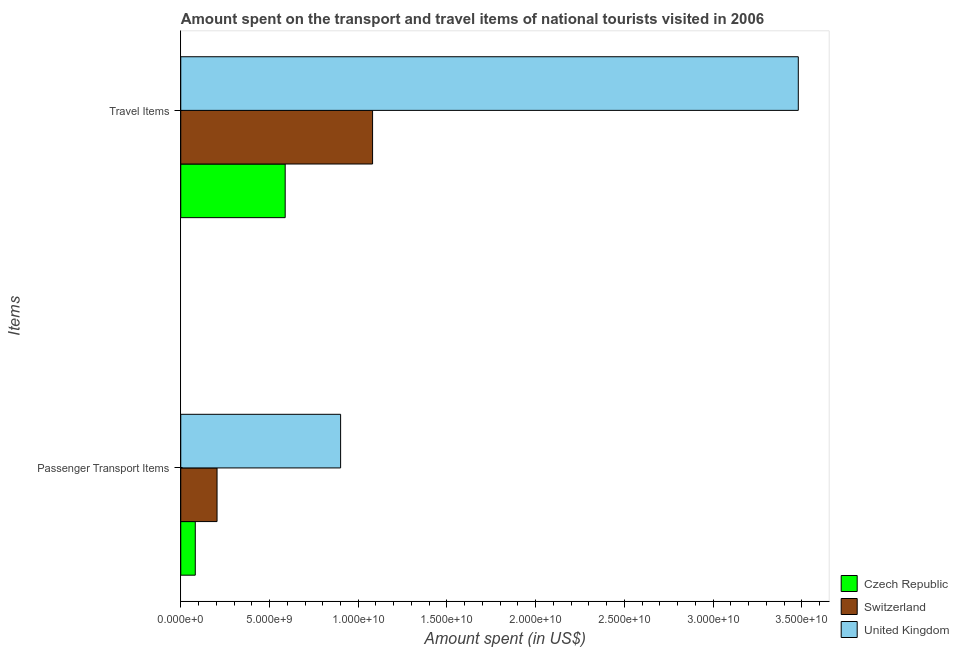Are the number of bars per tick equal to the number of legend labels?
Offer a very short reply. Yes. How many bars are there on the 2nd tick from the top?
Offer a terse response. 3. What is the label of the 2nd group of bars from the top?
Make the answer very short. Passenger Transport Items. What is the amount spent on passenger transport items in Czech Republic?
Your answer should be very brief. 8.18e+08. Across all countries, what is the maximum amount spent on passenger transport items?
Provide a succinct answer. 9.01e+09. Across all countries, what is the minimum amount spent on passenger transport items?
Your answer should be compact. 8.18e+08. In which country was the amount spent in travel items maximum?
Offer a terse response. United Kingdom. In which country was the amount spent on passenger transport items minimum?
Your response must be concise. Czech Republic. What is the total amount spent on passenger transport items in the graph?
Your response must be concise. 1.19e+1. What is the difference between the amount spent in travel items in Czech Republic and that in Switzerland?
Make the answer very short. -4.92e+09. What is the difference between the amount spent in travel items in United Kingdom and the amount spent on passenger transport items in Czech Republic?
Your answer should be very brief. 3.40e+1. What is the average amount spent on passenger transport items per country?
Give a very brief answer. 3.96e+09. What is the difference between the amount spent in travel items and amount spent on passenger transport items in Czech Republic?
Make the answer very short. 5.07e+09. What is the ratio of the amount spent on passenger transport items in Switzerland to that in Czech Republic?
Give a very brief answer. 2.5. What does the 2nd bar from the top in Passenger Transport Items represents?
Your response must be concise. Switzerland. What does the 1st bar from the bottom in Passenger Transport Items represents?
Your response must be concise. Czech Republic. How many bars are there?
Your answer should be compact. 6. How many countries are there in the graph?
Offer a terse response. 3. Are the values on the major ticks of X-axis written in scientific E-notation?
Ensure brevity in your answer.  Yes. Does the graph contain any zero values?
Make the answer very short. No. Does the graph contain grids?
Make the answer very short. No. How are the legend labels stacked?
Provide a succinct answer. Vertical. What is the title of the graph?
Your answer should be very brief. Amount spent on the transport and travel items of national tourists visited in 2006. What is the label or title of the X-axis?
Offer a terse response. Amount spent (in US$). What is the label or title of the Y-axis?
Give a very brief answer. Items. What is the Amount spent (in US$) in Czech Republic in Passenger Transport Items?
Offer a very short reply. 8.18e+08. What is the Amount spent (in US$) in Switzerland in Passenger Transport Items?
Provide a succinct answer. 2.04e+09. What is the Amount spent (in US$) of United Kingdom in Passenger Transport Items?
Give a very brief answer. 9.01e+09. What is the Amount spent (in US$) in Czech Republic in Travel Items?
Provide a succinct answer. 5.88e+09. What is the Amount spent (in US$) in Switzerland in Travel Items?
Your response must be concise. 1.08e+1. What is the Amount spent (in US$) of United Kingdom in Travel Items?
Make the answer very short. 3.48e+1. Across all Items, what is the maximum Amount spent (in US$) of Czech Republic?
Keep it short and to the point. 5.88e+09. Across all Items, what is the maximum Amount spent (in US$) of Switzerland?
Offer a very short reply. 1.08e+1. Across all Items, what is the maximum Amount spent (in US$) of United Kingdom?
Provide a short and direct response. 3.48e+1. Across all Items, what is the minimum Amount spent (in US$) of Czech Republic?
Offer a terse response. 8.18e+08. Across all Items, what is the minimum Amount spent (in US$) of Switzerland?
Make the answer very short. 2.04e+09. Across all Items, what is the minimum Amount spent (in US$) of United Kingdom?
Offer a terse response. 9.01e+09. What is the total Amount spent (in US$) in Czech Republic in the graph?
Ensure brevity in your answer.  6.70e+09. What is the total Amount spent (in US$) in Switzerland in the graph?
Provide a succinct answer. 1.29e+1. What is the total Amount spent (in US$) in United Kingdom in the graph?
Make the answer very short. 4.38e+1. What is the difference between the Amount spent (in US$) in Czech Republic in Passenger Transport Items and that in Travel Items?
Provide a short and direct response. -5.07e+09. What is the difference between the Amount spent (in US$) of Switzerland in Passenger Transport Items and that in Travel Items?
Offer a very short reply. -8.76e+09. What is the difference between the Amount spent (in US$) in United Kingdom in Passenger Transport Items and that in Travel Items?
Keep it short and to the point. -2.58e+1. What is the difference between the Amount spent (in US$) of Czech Republic in Passenger Transport Items and the Amount spent (in US$) of Switzerland in Travel Items?
Keep it short and to the point. -9.99e+09. What is the difference between the Amount spent (in US$) in Czech Republic in Passenger Transport Items and the Amount spent (in US$) in United Kingdom in Travel Items?
Provide a succinct answer. -3.40e+1. What is the difference between the Amount spent (in US$) in Switzerland in Passenger Transport Items and the Amount spent (in US$) in United Kingdom in Travel Items?
Offer a terse response. -3.28e+1. What is the average Amount spent (in US$) in Czech Republic per Items?
Your answer should be compact. 3.35e+09. What is the average Amount spent (in US$) of Switzerland per Items?
Your answer should be very brief. 6.43e+09. What is the average Amount spent (in US$) in United Kingdom per Items?
Your answer should be compact. 2.19e+1. What is the difference between the Amount spent (in US$) of Czech Republic and Amount spent (in US$) of Switzerland in Passenger Transport Items?
Keep it short and to the point. -1.23e+09. What is the difference between the Amount spent (in US$) of Czech Republic and Amount spent (in US$) of United Kingdom in Passenger Transport Items?
Give a very brief answer. -8.19e+09. What is the difference between the Amount spent (in US$) in Switzerland and Amount spent (in US$) in United Kingdom in Passenger Transport Items?
Ensure brevity in your answer.  -6.96e+09. What is the difference between the Amount spent (in US$) in Czech Republic and Amount spent (in US$) in Switzerland in Travel Items?
Provide a succinct answer. -4.92e+09. What is the difference between the Amount spent (in US$) in Czech Republic and Amount spent (in US$) in United Kingdom in Travel Items?
Your response must be concise. -2.89e+1. What is the difference between the Amount spent (in US$) in Switzerland and Amount spent (in US$) in United Kingdom in Travel Items?
Provide a succinct answer. -2.40e+1. What is the ratio of the Amount spent (in US$) of Czech Republic in Passenger Transport Items to that in Travel Items?
Keep it short and to the point. 0.14. What is the ratio of the Amount spent (in US$) of Switzerland in Passenger Transport Items to that in Travel Items?
Give a very brief answer. 0.19. What is the ratio of the Amount spent (in US$) in United Kingdom in Passenger Transport Items to that in Travel Items?
Give a very brief answer. 0.26. What is the difference between the highest and the second highest Amount spent (in US$) of Czech Republic?
Offer a terse response. 5.07e+09. What is the difference between the highest and the second highest Amount spent (in US$) in Switzerland?
Ensure brevity in your answer.  8.76e+09. What is the difference between the highest and the second highest Amount spent (in US$) in United Kingdom?
Your answer should be very brief. 2.58e+1. What is the difference between the highest and the lowest Amount spent (in US$) in Czech Republic?
Your response must be concise. 5.07e+09. What is the difference between the highest and the lowest Amount spent (in US$) of Switzerland?
Your response must be concise. 8.76e+09. What is the difference between the highest and the lowest Amount spent (in US$) of United Kingdom?
Your answer should be compact. 2.58e+1. 